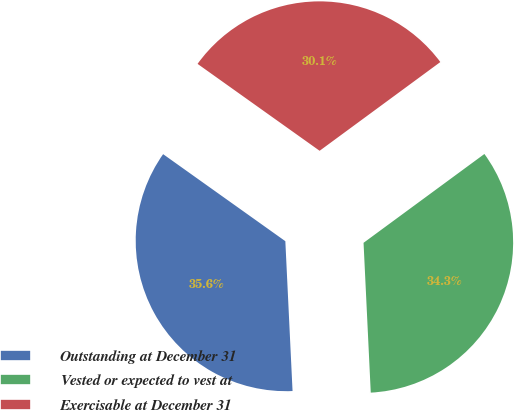<chart> <loc_0><loc_0><loc_500><loc_500><pie_chart><fcel>Outstanding at December 31<fcel>Vested or expected to vest at<fcel>Exercisable at December 31<nl><fcel>35.61%<fcel>34.32%<fcel>30.06%<nl></chart> 